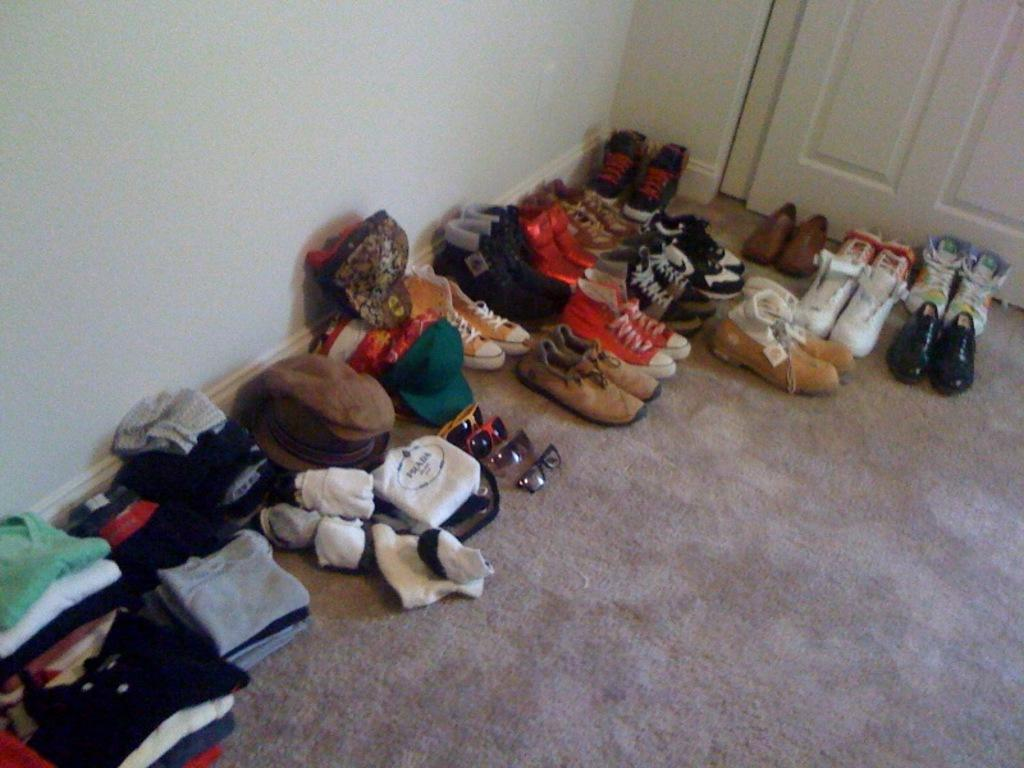What items can be seen on the surface in the image? There are clothes, goggles, and footwear on the surface in the image. What type of structure is visible at the top of the image? There is a wall and a door at the top of the image. What country is the hydrant from in the image? There is no hydrant present in the image. What type of vacation is being planned based on the items in the image? The image does not provide any information about a vacation or any plans related to it. 